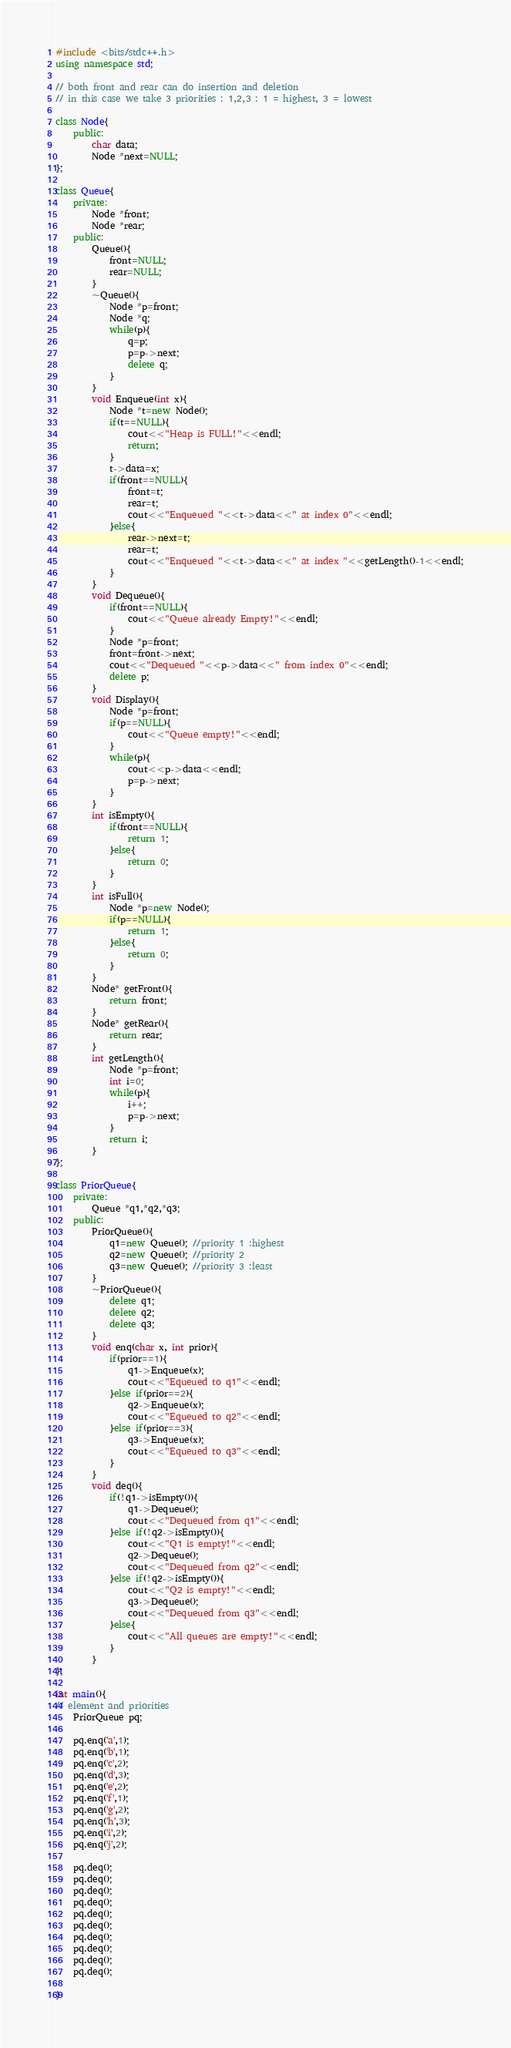Convert code to text. <code><loc_0><loc_0><loc_500><loc_500><_C++_>#include <bits/stdc++.h>
using namespace std;

// both front and rear can do insertion and deletion
// in this case we take 3 priorities : 1,2,3 : 1 = highest, 3 = lowest

class Node{
    public:
        char data;
        Node *next=NULL;
};

class Queue{
    private:
        Node *front;
        Node *rear;
    public:
        Queue(){
            front=NULL;
            rear=NULL;
        }
        ~Queue(){
            Node *p=front;
            Node *q;
            while(p){
                q=p;
                p=p->next;
                delete q;
            }
        }
        void Enqueue(int x){
            Node *t=new Node();
            if(t==NULL){
                cout<<"Heap is FULL!"<<endl;
                return;
            }
            t->data=x;
            if(front==NULL){
                front=t;
                rear=t;
                cout<<"Enqueued "<<t->data<<" at index 0"<<endl;
            }else{
                rear->next=t;
                rear=t;
                cout<<"Enqueued "<<t->data<<" at index "<<getLength()-1<<endl;
            }
        }
        void Dequeue(){
            if(front==NULL){
                cout<<"Queue already Empty!"<<endl;
            }
            Node *p=front;
            front=front->next;
            cout<<"Dequeued "<<p->data<<" from index 0"<<endl;
            delete p;
        }
        void Display(){
            Node *p=front;
            if(p==NULL){
                cout<<"Queue empty!"<<endl;
            }
            while(p){
                cout<<p->data<<endl;
                p=p->next;
            }
        }
        int isEmpty(){
            if(front==NULL){
                return 1;
            }else{
                return 0;
            }
        }
        int isFull(){
            Node *p=new Node();
            if(p==NULL){
                return 1;
            }else{
                return 0;
            }
        }
        Node* getFront(){
            return front;
        }
        Node* getRear(){
            return rear;
        }
        int getLength(){
            Node *p=front;
            int i=0;
            while(p){
                i++;
                p=p->next;
            }
            return i;
        }
};

class PriorQueue{
    private:
        Queue *q1,*q2,*q3;
    public:
        PriorQueue(){
            q1=new Queue(); //priority 1 :highest
            q2=new Queue(); //priority 2
            q3=new Queue(); //priority 3 :least
        }
        ~PriorQueue(){
            delete q1;
            delete q2;
            delete q3;
        }
        void enq(char x, int prior){
            if(prior==1){
                q1->Enqueue(x);
                cout<<"Equeued to q1"<<endl;
            }else if(prior==2){
                q2->Enqueue(x);
                cout<<"Equeued to q2"<<endl;
            }else if(prior==3){
                q3->Enqueue(x);
                cout<<"Equeued to q3"<<endl;
            }
        }
        void deq(){
            if(!q1->isEmpty()){
                q1->Dequeue();
                cout<<"Dequeued from q1"<<endl;
            }else if(!q2->isEmpty()){
                cout<<"Q1 is empty!"<<endl;
                q2->Dequeue();
                cout<<"Dequeued from q2"<<endl;
            }else if(!q2->isEmpty()){
                cout<<"Q2 is empty!"<<endl;
                q3->Dequeue();
                cout<<"Dequeued from q3"<<endl;
            }else{
                cout<<"All queues are empty!"<<endl;
            }
        }
};

int main(){
// element and priorities
    PriorQueue pq;
    
    pq.enq('a',1);
    pq.enq('b',1);
    pq.enq('c',2);
    pq.enq('d',3);
    pq.enq('e',2);
    pq.enq('f',1);
    pq.enq('g',2);
    pq.enq('h',3);
    pq.enq('i',2);
    pq.enq('j',2);

    pq.deq();
    pq.deq();
    pq.deq();
    pq.deq();
    pq.deq();
    pq.deq();
    pq.deq();
    pq.deq();
    pq.deq();
    pq.deq();

}</code> 